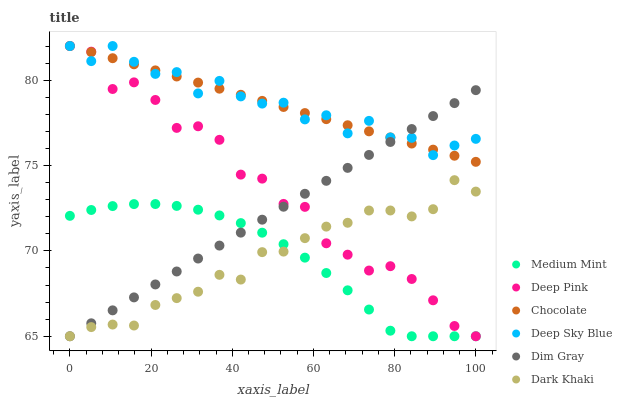Does Dark Khaki have the minimum area under the curve?
Answer yes or no. Yes. Does Deep Sky Blue have the maximum area under the curve?
Answer yes or no. Yes. Does Dim Gray have the minimum area under the curve?
Answer yes or no. No. Does Dim Gray have the maximum area under the curve?
Answer yes or no. No. Is Chocolate the smoothest?
Answer yes or no. Yes. Is Deep Pink the roughest?
Answer yes or no. Yes. Is Dim Gray the smoothest?
Answer yes or no. No. Is Dim Gray the roughest?
Answer yes or no. No. Does Medium Mint have the lowest value?
Answer yes or no. Yes. Does Chocolate have the lowest value?
Answer yes or no. No. Does Deep Sky Blue have the highest value?
Answer yes or no. Yes. Does Dim Gray have the highest value?
Answer yes or no. No. Is Dark Khaki less than Chocolate?
Answer yes or no. Yes. Is Deep Sky Blue greater than Medium Mint?
Answer yes or no. Yes. Does Chocolate intersect Dim Gray?
Answer yes or no. Yes. Is Chocolate less than Dim Gray?
Answer yes or no. No. Is Chocolate greater than Dim Gray?
Answer yes or no. No. Does Dark Khaki intersect Chocolate?
Answer yes or no. No. 